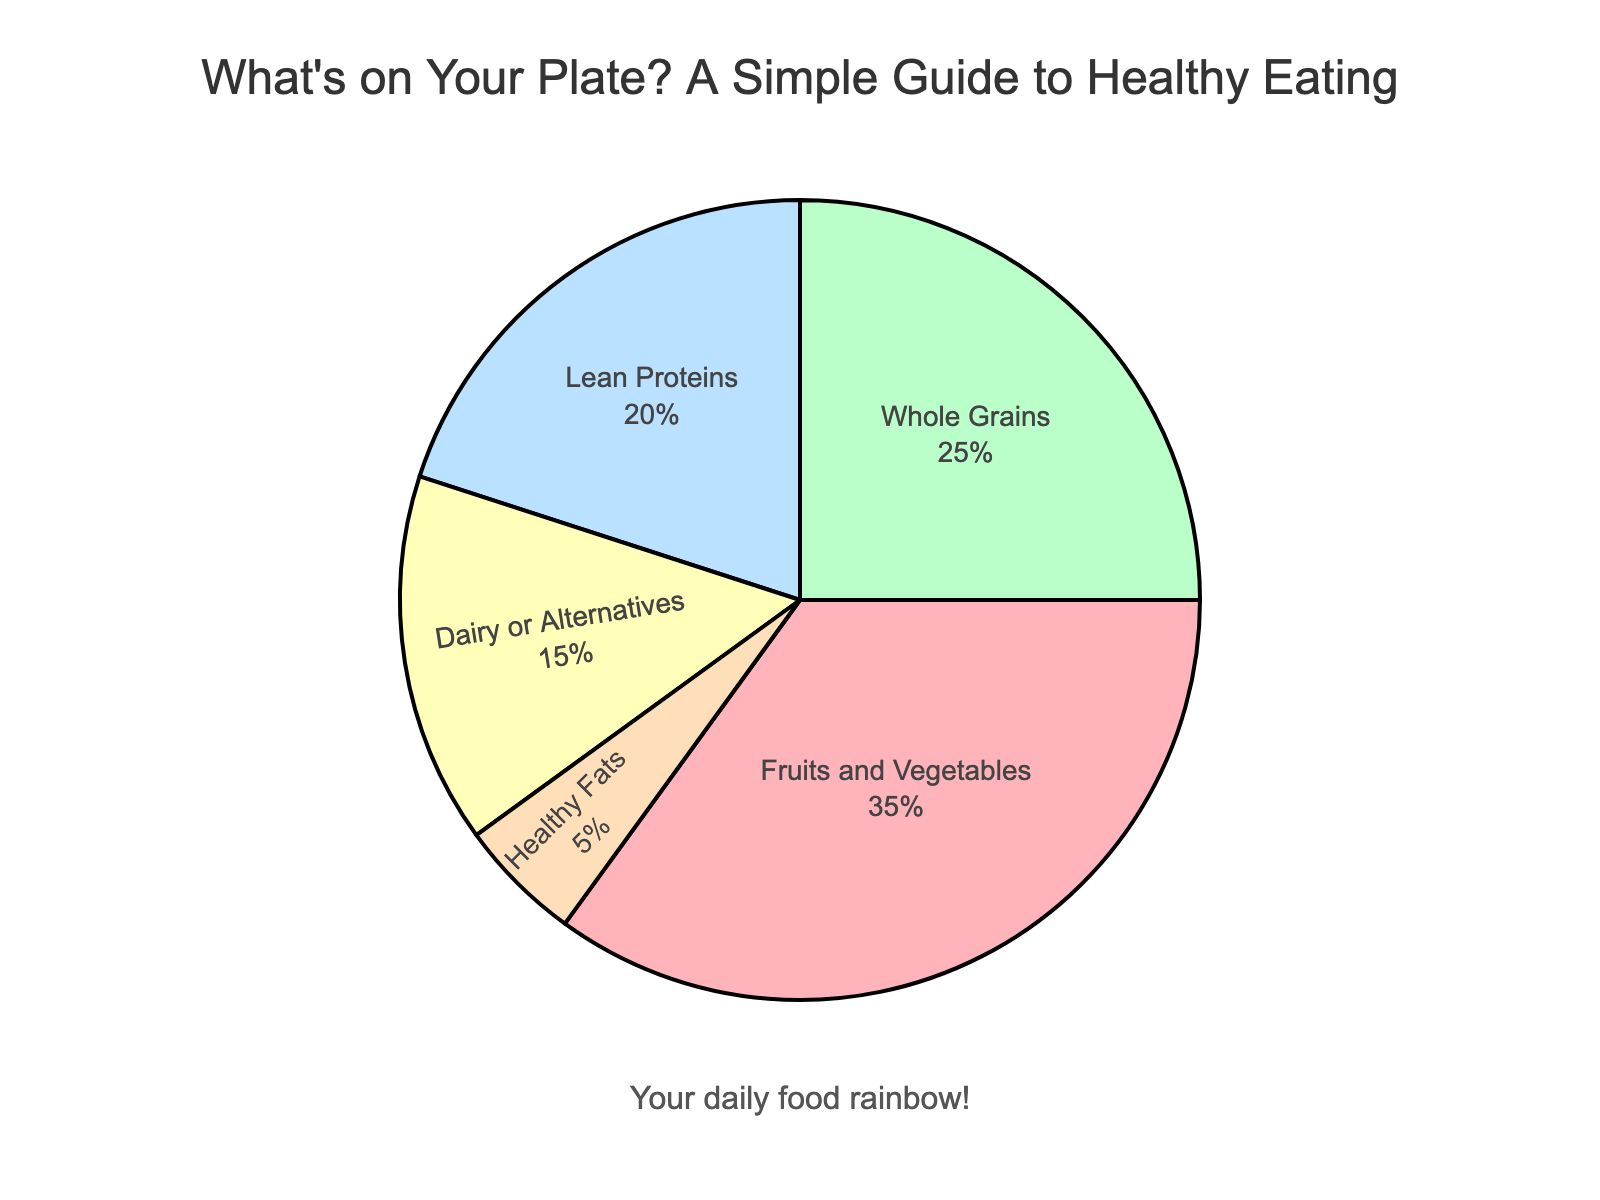What's the largest food group in terms of percentage? Look at the food group with the highest percentage. "Fruits and Vegetables" is the largest, with 35%.
Answer: Fruits and Vegetables Which food group makes up the smallest portion of the diet? Identify the group with the lowest percentage in the pie chart. "Healthy Fats" is the smallest, at 5%.
Answer: Healthy Fats What's the total percentage of Whole Grains and Lean Proteins together? Add the percentages of "Whole Grains" and "Lean Proteins": 25% + 20% = 45%.
Answer: 45% How much higher is the percentage of Fruits and Vegetables compared to Dairy or Alternatives? Subtract the percentage of "Dairy or Alternatives" from "Fruits and Vegetables": 35% - 15% = 20%.
Answer: 20% Which two food groups together make up exactly half of the recommended diet? Find two groups whose percentages sum to 50%. "Whole Grains" (25%) and "Lean Proteins" (20%) together with "Healthy Fats" (5%) equals 25% + 20% + 5% = 50%.
Answer: Whole Grains and Lean Proteins What does the legend and the text in the figure tell you about the importance of variety in your diet? The legend isn't shown separately, but the pie chart and the text highlight various food groups crucial for a balanced diet. The title and annotations emphasize the need for variety.
Answer: Variety is important Which food group is represented by the green color segment in the pie chart? Observe the green segment in the pie chart. It corresponds to "Whole Grains".
Answer: Whole Grains What percentage of the diet should come from Dairy or Alternatives and Healthy Fats combined? Add the percentages of "Dairy or Alternatives" and "Healthy Fats": 15% + 5% = 20%.
Answer: 20% Is the percentage of Lean Proteins in the diet greater or less than that of Dairy or Alternatives? Compare the percentages of "Lean Proteins" (20%) and "Dairy or Alternatives" (15%).
Answer: Greater 